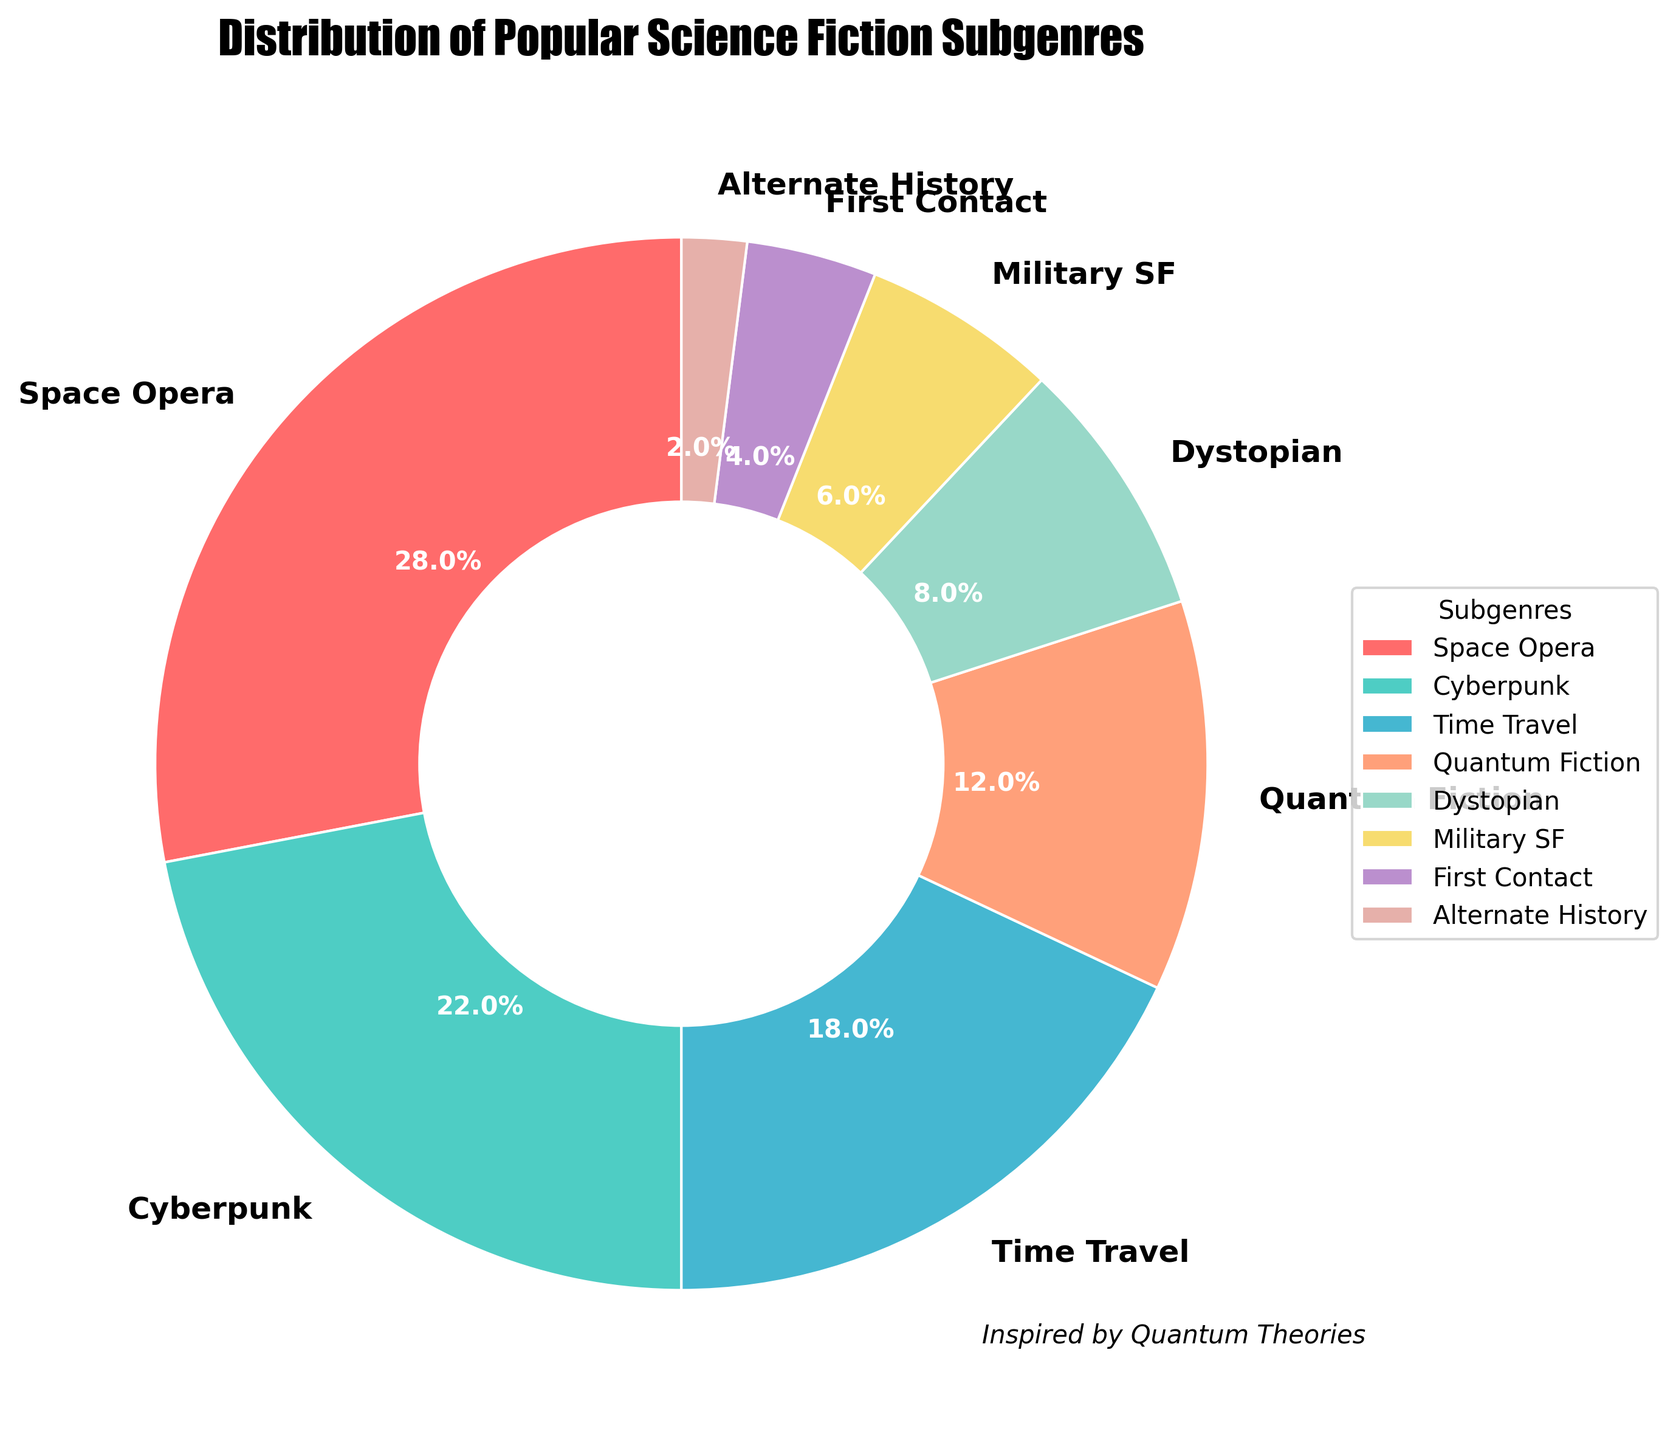What is the subgenre with the highest percentage? The slice labeled 'Space Opera' takes up the largest portion of the pie chart.
Answer: Space Opera Which two subgenres together make up the largest portion of the pie chart? The largest percentage is from 'Space Opera' (28%) and the second largest is from 'Cyberpunk' (22%). Together, they make 28% + 22% = 50%.
Answer: Space Opera and Cyberpunk Is 'Time Travel' more common than 'Dystopian'? Yes, the 'Time Travel' segment shows 18% while the 'Dystopian' segment shows 8%. Thus, Time Travel has a higher percentage.
Answer: Yes Which subgenres are represented by blue and purple colors respectively? The subgenre labeled 'Quantum Fiction' is colored blue and the subgenre labeled 'Alternate History' is colored purple.
Answer: Quantum Fiction and Alternate History What is the combined percentage of the subgenres that have less than 10% representation each? The subgenres with less than 10% are 'Dystopian' (8%), 'Military SF' (6%), 'First Contact' (4%), and 'Alternate History' (2%). Summing these up: 8% + 6% + 4% + 2% = 20%.
Answer: 20% How much more popular is 'Space Opera' than 'Military SF'? The 'Space Opera' segment has 28% and the 'Military SF' segment has 6%. The difference is 28% - 6% = 22%.
Answer: 22% Which subgenre occupies the fourth largest slice of the pie chart? The subgenre with the fourth largest percentage is 'Quantum Fiction' at 12%.
Answer: Quantum Fiction Rank the subgenres from most to least popular. Based on the percentages: (1) Space Opera (28%), (2) Cyberpunk (22%), (3) Time Travel (18%), (4) Quantum Fiction (12%), (5) Dystopian (8%), (6) Military SF (6%), (7) First Contact (4%), (8) Alternate History (2%).
Answer: Space Opera > Cyberpunk > Time Travel > Quantum Fiction > Dystopian > Military SF > First Contact > Alternate History 